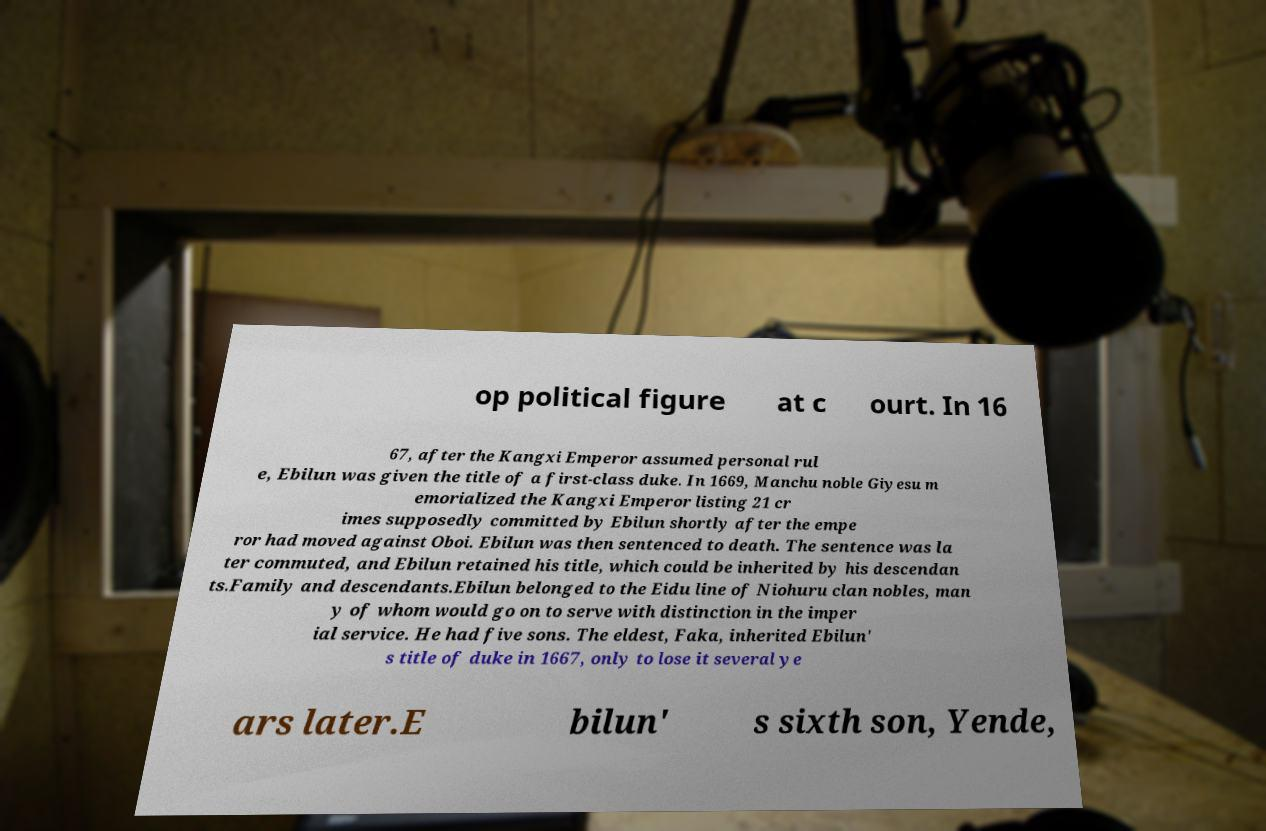Could you extract and type out the text from this image? op political figure at c ourt. In 16 67, after the Kangxi Emperor assumed personal rul e, Ebilun was given the title of a first-class duke. In 1669, Manchu noble Giyesu m emorialized the Kangxi Emperor listing 21 cr imes supposedly committed by Ebilun shortly after the empe ror had moved against Oboi. Ebilun was then sentenced to death. The sentence was la ter commuted, and Ebilun retained his title, which could be inherited by his descendan ts.Family and descendants.Ebilun belonged to the Eidu line of Niohuru clan nobles, man y of whom would go on to serve with distinction in the imper ial service. He had five sons. The eldest, Faka, inherited Ebilun' s title of duke in 1667, only to lose it several ye ars later.E bilun' s sixth son, Yende, 